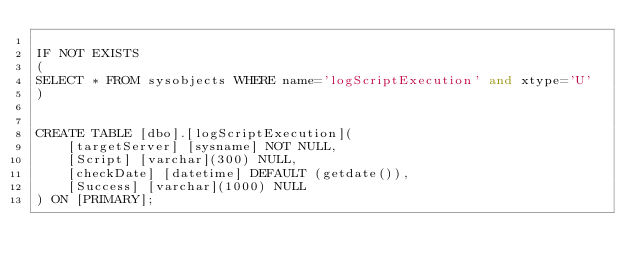<code> <loc_0><loc_0><loc_500><loc_500><_SQL_>
IF NOT EXISTS 
(
SELECT * FROM sysobjects WHERE name='logScriptExecution' and xtype='U'
)


CREATE TABLE [dbo].[logScriptExecution](
	[targetServer] [sysname] NOT NULL,
	[Script] [varchar](300) NULL,
	[checkDate] [datetime] DEFAULT (getdate()),
	[Success] [varchar](1000) NULL
) ON [PRIMARY];</code> 